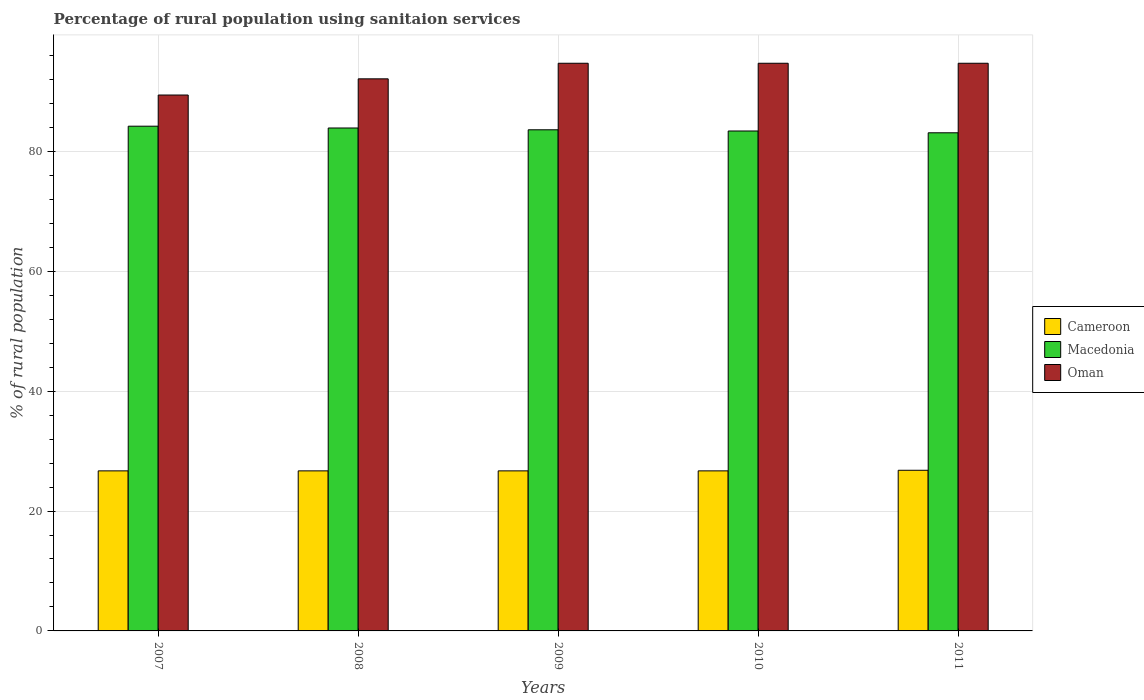How many different coloured bars are there?
Your response must be concise. 3. How many groups of bars are there?
Keep it short and to the point. 5. How many bars are there on the 3rd tick from the right?
Offer a terse response. 3. In how many cases, is the number of bars for a given year not equal to the number of legend labels?
Offer a very short reply. 0. What is the percentage of rural population using sanitaion services in Oman in 2007?
Provide a short and direct response. 89.4. Across all years, what is the maximum percentage of rural population using sanitaion services in Macedonia?
Your answer should be very brief. 84.2. Across all years, what is the minimum percentage of rural population using sanitaion services in Macedonia?
Your answer should be compact. 83.1. In which year was the percentage of rural population using sanitaion services in Oman minimum?
Your answer should be very brief. 2007. What is the total percentage of rural population using sanitaion services in Cameroon in the graph?
Your answer should be compact. 133.6. What is the difference between the percentage of rural population using sanitaion services in Cameroon in 2009 and that in 2011?
Offer a terse response. -0.1. What is the difference between the percentage of rural population using sanitaion services in Macedonia in 2008 and the percentage of rural population using sanitaion services in Oman in 2011?
Offer a very short reply. -10.8. What is the average percentage of rural population using sanitaion services in Cameroon per year?
Your response must be concise. 26.72. In the year 2008, what is the difference between the percentage of rural population using sanitaion services in Macedonia and percentage of rural population using sanitaion services in Oman?
Your answer should be compact. -8.2. What is the ratio of the percentage of rural population using sanitaion services in Macedonia in 2007 to that in 2011?
Your answer should be very brief. 1.01. Is the percentage of rural population using sanitaion services in Oman in 2008 less than that in 2010?
Your answer should be compact. Yes. What is the difference between the highest and the second highest percentage of rural population using sanitaion services in Macedonia?
Provide a succinct answer. 0.3. What is the difference between the highest and the lowest percentage of rural population using sanitaion services in Oman?
Give a very brief answer. 5.3. In how many years, is the percentage of rural population using sanitaion services in Macedonia greater than the average percentage of rural population using sanitaion services in Macedonia taken over all years?
Make the answer very short. 2. Is the sum of the percentage of rural population using sanitaion services in Cameroon in 2009 and 2010 greater than the maximum percentage of rural population using sanitaion services in Macedonia across all years?
Your answer should be compact. No. What does the 2nd bar from the left in 2007 represents?
Give a very brief answer. Macedonia. What does the 3rd bar from the right in 2010 represents?
Offer a terse response. Cameroon. How many bars are there?
Make the answer very short. 15. Are all the bars in the graph horizontal?
Provide a short and direct response. No. What is the difference between two consecutive major ticks on the Y-axis?
Your response must be concise. 20. Does the graph contain any zero values?
Offer a terse response. No. Where does the legend appear in the graph?
Offer a very short reply. Center right. What is the title of the graph?
Make the answer very short. Percentage of rural population using sanitaion services. What is the label or title of the Y-axis?
Your answer should be compact. % of rural population. What is the % of rural population of Cameroon in 2007?
Ensure brevity in your answer.  26.7. What is the % of rural population of Macedonia in 2007?
Make the answer very short. 84.2. What is the % of rural population in Oman in 2007?
Offer a very short reply. 89.4. What is the % of rural population of Cameroon in 2008?
Keep it short and to the point. 26.7. What is the % of rural population of Macedonia in 2008?
Make the answer very short. 83.9. What is the % of rural population of Oman in 2008?
Give a very brief answer. 92.1. What is the % of rural population of Cameroon in 2009?
Your response must be concise. 26.7. What is the % of rural population in Macedonia in 2009?
Give a very brief answer. 83.6. What is the % of rural population in Oman in 2009?
Offer a very short reply. 94.7. What is the % of rural population of Cameroon in 2010?
Provide a short and direct response. 26.7. What is the % of rural population in Macedonia in 2010?
Offer a terse response. 83.4. What is the % of rural population of Oman in 2010?
Your answer should be very brief. 94.7. What is the % of rural population of Cameroon in 2011?
Your response must be concise. 26.8. What is the % of rural population of Macedonia in 2011?
Offer a terse response. 83.1. What is the % of rural population in Oman in 2011?
Ensure brevity in your answer.  94.7. Across all years, what is the maximum % of rural population in Cameroon?
Offer a terse response. 26.8. Across all years, what is the maximum % of rural population in Macedonia?
Your answer should be compact. 84.2. Across all years, what is the maximum % of rural population in Oman?
Keep it short and to the point. 94.7. Across all years, what is the minimum % of rural population in Cameroon?
Offer a very short reply. 26.7. Across all years, what is the minimum % of rural population of Macedonia?
Provide a succinct answer. 83.1. Across all years, what is the minimum % of rural population in Oman?
Keep it short and to the point. 89.4. What is the total % of rural population of Cameroon in the graph?
Offer a very short reply. 133.6. What is the total % of rural population in Macedonia in the graph?
Offer a very short reply. 418.2. What is the total % of rural population of Oman in the graph?
Your answer should be very brief. 465.6. What is the difference between the % of rural population in Macedonia in 2007 and that in 2008?
Give a very brief answer. 0.3. What is the difference between the % of rural population in Oman in 2007 and that in 2008?
Give a very brief answer. -2.7. What is the difference between the % of rural population of Oman in 2007 and that in 2009?
Keep it short and to the point. -5.3. What is the difference between the % of rural population in Cameroon in 2008 and that in 2009?
Make the answer very short. 0. What is the difference between the % of rural population in Macedonia in 2008 and that in 2009?
Give a very brief answer. 0.3. What is the difference between the % of rural population of Oman in 2008 and that in 2009?
Your response must be concise. -2.6. What is the difference between the % of rural population in Cameroon in 2008 and that in 2010?
Provide a short and direct response. 0. What is the difference between the % of rural population in Oman in 2008 and that in 2010?
Give a very brief answer. -2.6. What is the difference between the % of rural population in Cameroon in 2008 and that in 2011?
Make the answer very short. -0.1. What is the difference between the % of rural population in Macedonia in 2008 and that in 2011?
Ensure brevity in your answer.  0.8. What is the difference between the % of rural population of Macedonia in 2009 and that in 2010?
Provide a short and direct response. 0.2. What is the difference between the % of rural population in Cameroon in 2009 and that in 2011?
Keep it short and to the point. -0.1. What is the difference between the % of rural population of Macedonia in 2009 and that in 2011?
Ensure brevity in your answer.  0.5. What is the difference between the % of rural population in Oman in 2010 and that in 2011?
Your response must be concise. 0. What is the difference between the % of rural population of Cameroon in 2007 and the % of rural population of Macedonia in 2008?
Your response must be concise. -57.2. What is the difference between the % of rural population of Cameroon in 2007 and the % of rural population of Oman in 2008?
Your response must be concise. -65.4. What is the difference between the % of rural population in Macedonia in 2007 and the % of rural population in Oman in 2008?
Give a very brief answer. -7.9. What is the difference between the % of rural population of Cameroon in 2007 and the % of rural population of Macedonia in 2009?
Give a very brief answer. -56.9. What is the difference between the % of rural population of Cameroon in 2007 and the % of rural population of Oman in 2009?
Ensure brevity in your answer.  -68. What is the difference between the % of rural population in Cameroon in 2007 and the % of rural population in Macedonia in 2010?
Your answer should be very brief. -56.7. What is the difference between the % of rural population of Cameroon in 2007 and the % of rural population of Oman in 2010?
Ensure brevity in your answer.  -68. What is the difference between the % of rural population of Macedonia in 2007 and the % of rural population of Oman in 2010?
Give a very brief answer. -10.5. What is the difference between the % of rural population in Cameroon in 2007 and the % of rural population in Macedonia in 2011?
Your answer should be compact. -56.4. What is the difference between the % of rural population in Cameroon in 2007 and the % of rural population in Oman in 2011?
Provide a succinct answer. -68. What is the difference between the % of rural population in Cameroon in 2008 and the % of rural population in Macedonia in 2009?
Keep it short and to the point. -56.9. What is the difference between the % of rural population of Cameroon in 2008 and the % of rural population of Oman in 2009?
Offer a terse response. -68. What is the difference between the % of rural population of Cameroon in 2008 and the % of rural population of Macedonia in 2010?
Provide a short and direct response. -56.7. What is the difference between the % of rural population of Cameroon in 2008 and the % of rural population of Oman in 2010?
Provide a succinct answer. -68. What is the difference between the % of rural population of Macedonia in 2008 and the % of rural population of Oman in 2010?
Provide a succinct answer. -10.8. What is the difference between the % of rural population of Cameroon in 2008 and the % of rural population of Macedonia in 2011?
Provide a short and direct response. -56.4. What is the difference between the % of rural population of Cameroon in 2008 and the % of rural population of Oman in 2011?
Provide a succinct answer. -68. What is the difference between the % of rural population of Cameroon in 2009 and the % of rural population of Macedonia in 2010?
Offer a terse response. -56.7. What is the difference between the % of rural population in Cameroon in 2009 and the % of rural population in Oman in 2010?
Offer a very short reply. -68. What is the difference between the % of rural population in Cameroon in 2009 and the % of rural population in Macedonia in 2011?
Provide a short and direct response. -56.4. What is the difference between the % of rural population of Cameroon in 2009 and the % of rural population of Oman in 2011?
Make the answer very short. -68. What is the difference between the % of rural population of Macedonia in 2009 and the % of rural population of Oman in 2011?
Give a very brief answer. -11.1. What is the difference between the % of rural population in Cameroon in 2010 and the % of rural population in Macedonia in 2011?
Make the answer very short. -56.4. What is the difference between the % of rural population of Cameroon in 2010 and the % of rural population of Oman in 2011?
Your answer should be compact. -68. What is the average % of rural population in Cameroon per year?
Your answer should be very brief. 26.72. What is the average % of rural population of Macedonia per year?
Give a very brief answer. 83.64. What is the average % of rural population of Oman per year?
Make the answer very short. 93.12. In the year 2007, what is the difference between the % of rural population in Cameroon and % of rural population in Macedonia?
Your response must be concise. -57.5. In the year 2007, what is the difference between the % of rural population in Cameroon and % of rural population in Oman?
Give a very brief answer. -62.7. In the year 2008, what is the difference between the % of rural population in Cameroon and % of rural population in Macedonia?
Your answer should be compact. -57.2. In the year 2008, what is the difference between the % of rural population of Cameroon and % of rural population of Oman?
Offer a very short reply. -65.4. In the year 2009, what is the difference between the % of rural population in Cameroon and % of rural population in Macedonia?
Your answer should be very brief. -56.9. In the year 2009, what is the difference between the % of rural population in Cameroon and % of rural population in Oman?
Make the answer very short. -68. In the year 2010, what is the difference between the % of rural population of Cameroon and % of rural population of Macedonia?
Your answer should be very brief. -56.7. In the year 2010, what is the difference between the % of rural population of Cameroon and % of rural population of Oman?
Ensure brevity in your answer.  -68. In the year 2011, what is the difference between the % of rural population of Cameroon and % of rural population of Macedonia?
Ensure brevity in your answer.  -56.3. In the year 2011, what is the difference between the % of rural population of Cameroon and % of rural population of Oman?
Provide a succinct answer. -67.9. What is the ratio of the % of rural population of Cameroon in 2007 to that in 2008?
Give a very brief answer. 1. What is the ratio of the % of rural population of Oman in 2007 to that in 2008?
Give a very brief answer. 0.97. What is the ratio of the % of rural population of Cameroon in 2007 to that in 2009?
Keep it short and to the point. 1. What is the ratio of the % of rural population of Macedonia in 2007 to that in 2009?
Offer a terse response. 1.01. What is the ratio of the % of rural population in Oman in 2007 to that in 2009?
Your answer should be compact. 0.94. What is the ratio of the % of rural population in Macedonia in 2007 to that in 2010?
Provide a succinct answer. 1.01. What is the ratio of the % of rural population of Oman in 2007 to that in 2010?
Keep it short and to the point. 0.94. What is the ratio of the % of rural population in Cameroon in 2007 to that in 2011?
Offer a very short reply. 1. What is the ratio of the % of rural population in Macedonia in 2007 to that in 2011?
Make the answer very short. 1.01. What is the ratio of the % of rural population in Oman in 2007 to that in 2011?
Your answer should be very brief. 0.94. What is the ratio of the % of rural population of Cameroon in 2008 to that in 2009?
Offer a very short reply. 1. What is the ratio of the % of rural population of Macedonia in 2008 to that in 2009?
Your response must be concise. 1. What is the ratio of the % of rural population of Oman in 2008 to that in 2009?
Provide a short and direct response. 0.97. What is the ratio of the % of rural population in Cameroon in 2008 to that in 2010?
Provide a succinct answer. 1. What is the ratio of the % of rural population of Macedonia in 2008 to that in 2010?
Offer a terse response. 1.01. What is the ratio of the % of rural population in Oman in 2008 to that in 2010?
Offer a very short reply. 0.97. What is the ratio of the % of rural population in Cameroon in 2008 to that in 2011?
Provide a succinct answer. 1. What is the ratio of the % of rural population of Macedonia in 2008 to that in 2011?
Provide a short and direct response. 1.01. What is the ratio of the % of rural population in Oman in 2008 to that in 2011?
Make the answer very short. 0.97. What is the ratio of the % of rural population in Oman in 2009 to that in 2010?
Your answer should be very brief. 1. What is the ratio of the % of rural population of Macedonia in 2009 to that in 2011?
Ensure brevity in your answer.  1.01. What is the ratio of the % of rural population of Cameroon in 2010 to that in 2011?
Offer a very short reply. 1. What is the ratio of the % of rural population in Macedonia in 2010 to that in 2011?
Keep it short and to the point. 1. What is the difference between the highest and the second highest % of rural population of Cameroon?
Offer a terse response. 0.1. What is the difference between the highest and the second highest % of rural population in Macedonia?
Your answer should be very brief. 0.3. What is the difference between the highest and the lowest % of rural population in Cameroon?
Offer a very short reply. 0.1. What is the difference between the highest and the lowest % of rural population of Oman?
Your response must be concise. 5.3. 